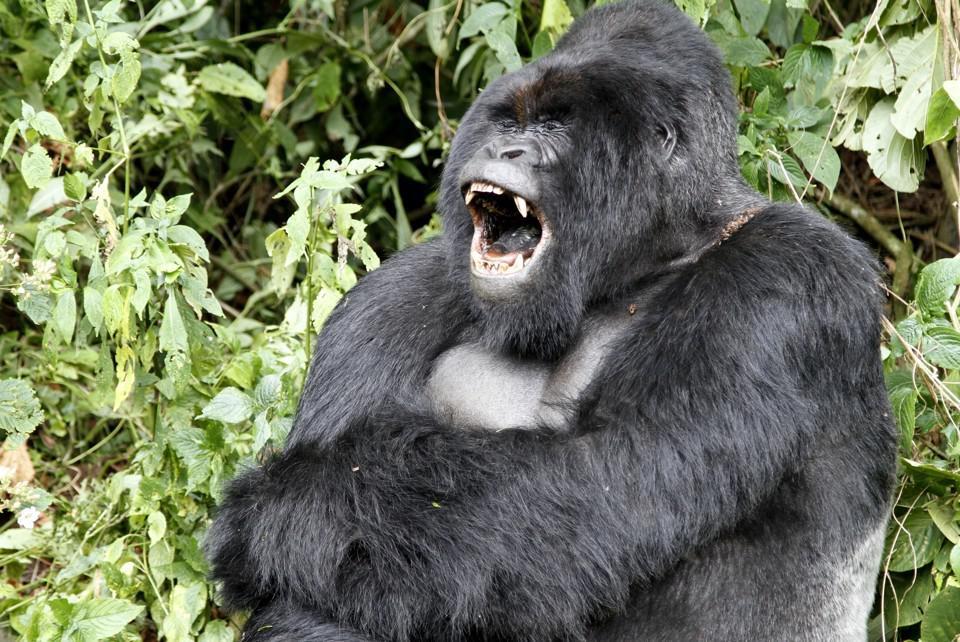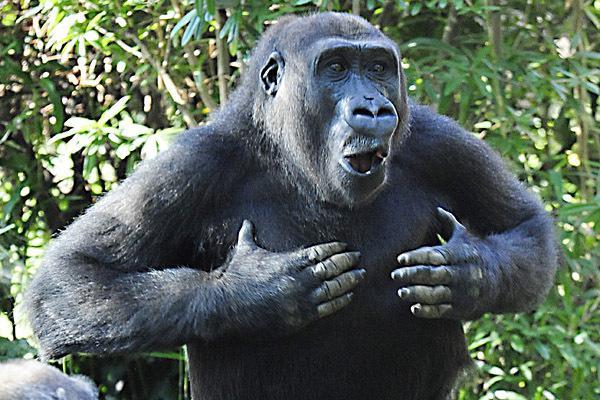The first image is the image on the left, the second image is the image on the right. Evaluate the accuracy of this statement regarding the images: "the left and right image contains the same number of gorillas.". Is it true? Answer yes or no. Yes. The first image is the image on the left, the second image is the image on the right. Assess this claim about the two images: "There is a silverback gorilla sitting while crossing his arm over the other". Correct or not? Answer yes or no. Yes. 